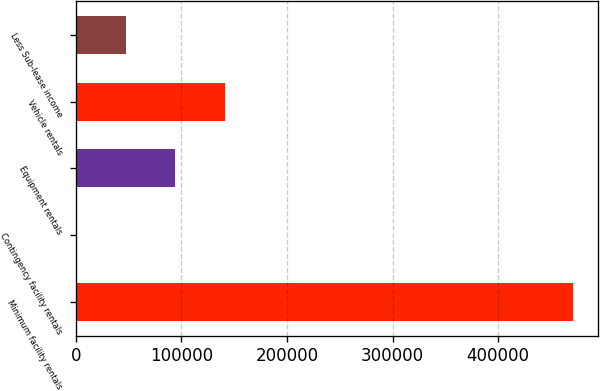Convert chart. <chart><loc_0><loc_0><loc_500><loc_500><bar_chart><fcel>Minimum facility rentals<fcel>Contingency facility rentals<fcel>Equipment rentals<fcel>Vehicle rentals<fcel>Less Sub-lease income<nl><fcel>471061<fcel>303<fcel>94454.6<fcel>141530<fcel>47378.8<nl></chart> 